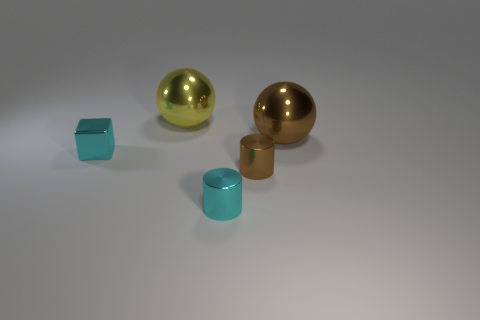What number of objects are either shiny things that are in front of the tiny metallic block or tiny things?
Your answer should be very brief. 3. Is there a big yellow object of the same shape as the large brown thing?
Make the answer very short. Yes. The large brown metal object that is behind the tiny object to the left of the cyan cylinder is what shape?
Your answer should be very brief. Sphere. How many cylinders are tiny cyan rubber things or big yellow things?
Give a very brief answer. 0. There is a brown object right of the tiny brown thing; does it have the same shape as the big metal object that is on the left side of the large brown shiny object?
Ensure brevity in your answer.  Yes. There is a thing that is on the right side of the big yellow shiny ball and behind the small brown metallic cylinder; what color is it?
Offer a terse response. Brown. Do the shiny cube and the tiny thing in front of the tiny brown cylinder have the same color?
Make the answer very short. Yes. There is a shiny object that is on the right side of the yellow ball and behind the brown metal cylinder; what is its size?
Provide a short and direct response. Large. How many other things are there of the same color as the cube?
Ensure brevity in your answer.  1. There is a metallic ball that is behind the big metallic sphere on the right side of the cyan thing right of the cyan metal block; how big is it?
Provide a succinct answer. Large. 